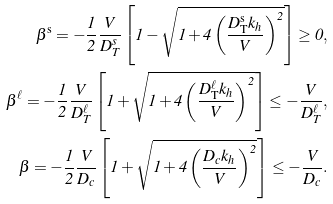<formula> <loc_0><loc_0><loc_500><loc_500>\beta ^ { \mathrm s } = - \frac { 1 } { 2 } \frac { V } { D _ { T } ^ { s } } \left [ 1 - \sqrt { 1 + 4 \left ( \frac { D _ { \mathrm T } ^ { \mathrm s } k _ { h } } { V } \right ) ^ { 2 } } \right ] \geq 0 , \\ \beta ^ { \ell } = - \frac { 1 } { 2 } \frac { V } { D _ { T } ^ { \ell } } \left [ 1 + \sqrt { 1 + 4 \left ( \frac { D _ { \mathrm T } ^ { \ell } k _ { h } } { V } \right ) ^ { 2 } } \right ] \leq - \frac { V } { D _ { T } ^ { \ell } } , \\ \beta = - \frac { 1 } { 2 } \frac { V } { D _ { c } } \left [ 1 + \sqrt { 1 + 4 \left ( \frac { D _ { c } k _ { h } } { V } \right ) ^ { 2 } } \right ] \leq - \frac { V } { D _ { c } } . \\</formula> 